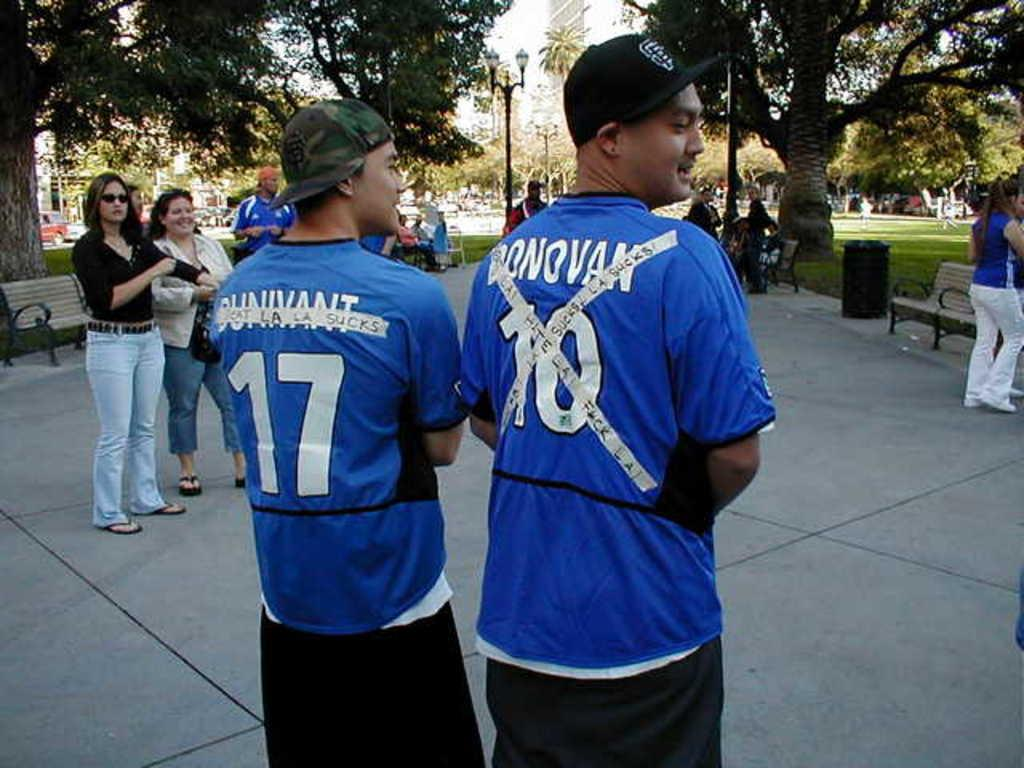Provide a one-sentence caption for the provided image. a couple guys in blue shirts with one wearing the number 10. 